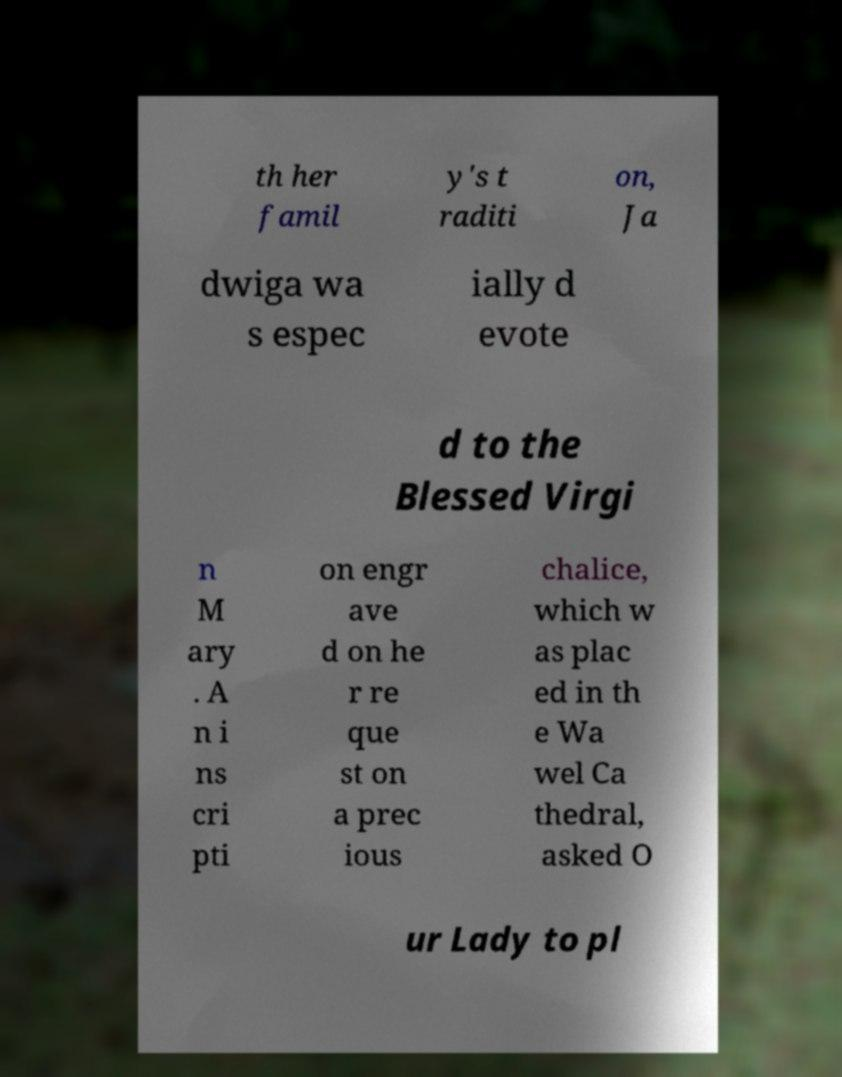Can you accurately transcribe the text from the provided image for me? th her famil y's t raditi on, Ja dwiga wa s espec ially d evote d to the Blessed Virgi n M ary . A n i ns cri pti on engr ave d on he r re que st on a prec ious chalice, which w as plac ed in th e Wa wel Ca thedral, asked O ur Lady to pl 